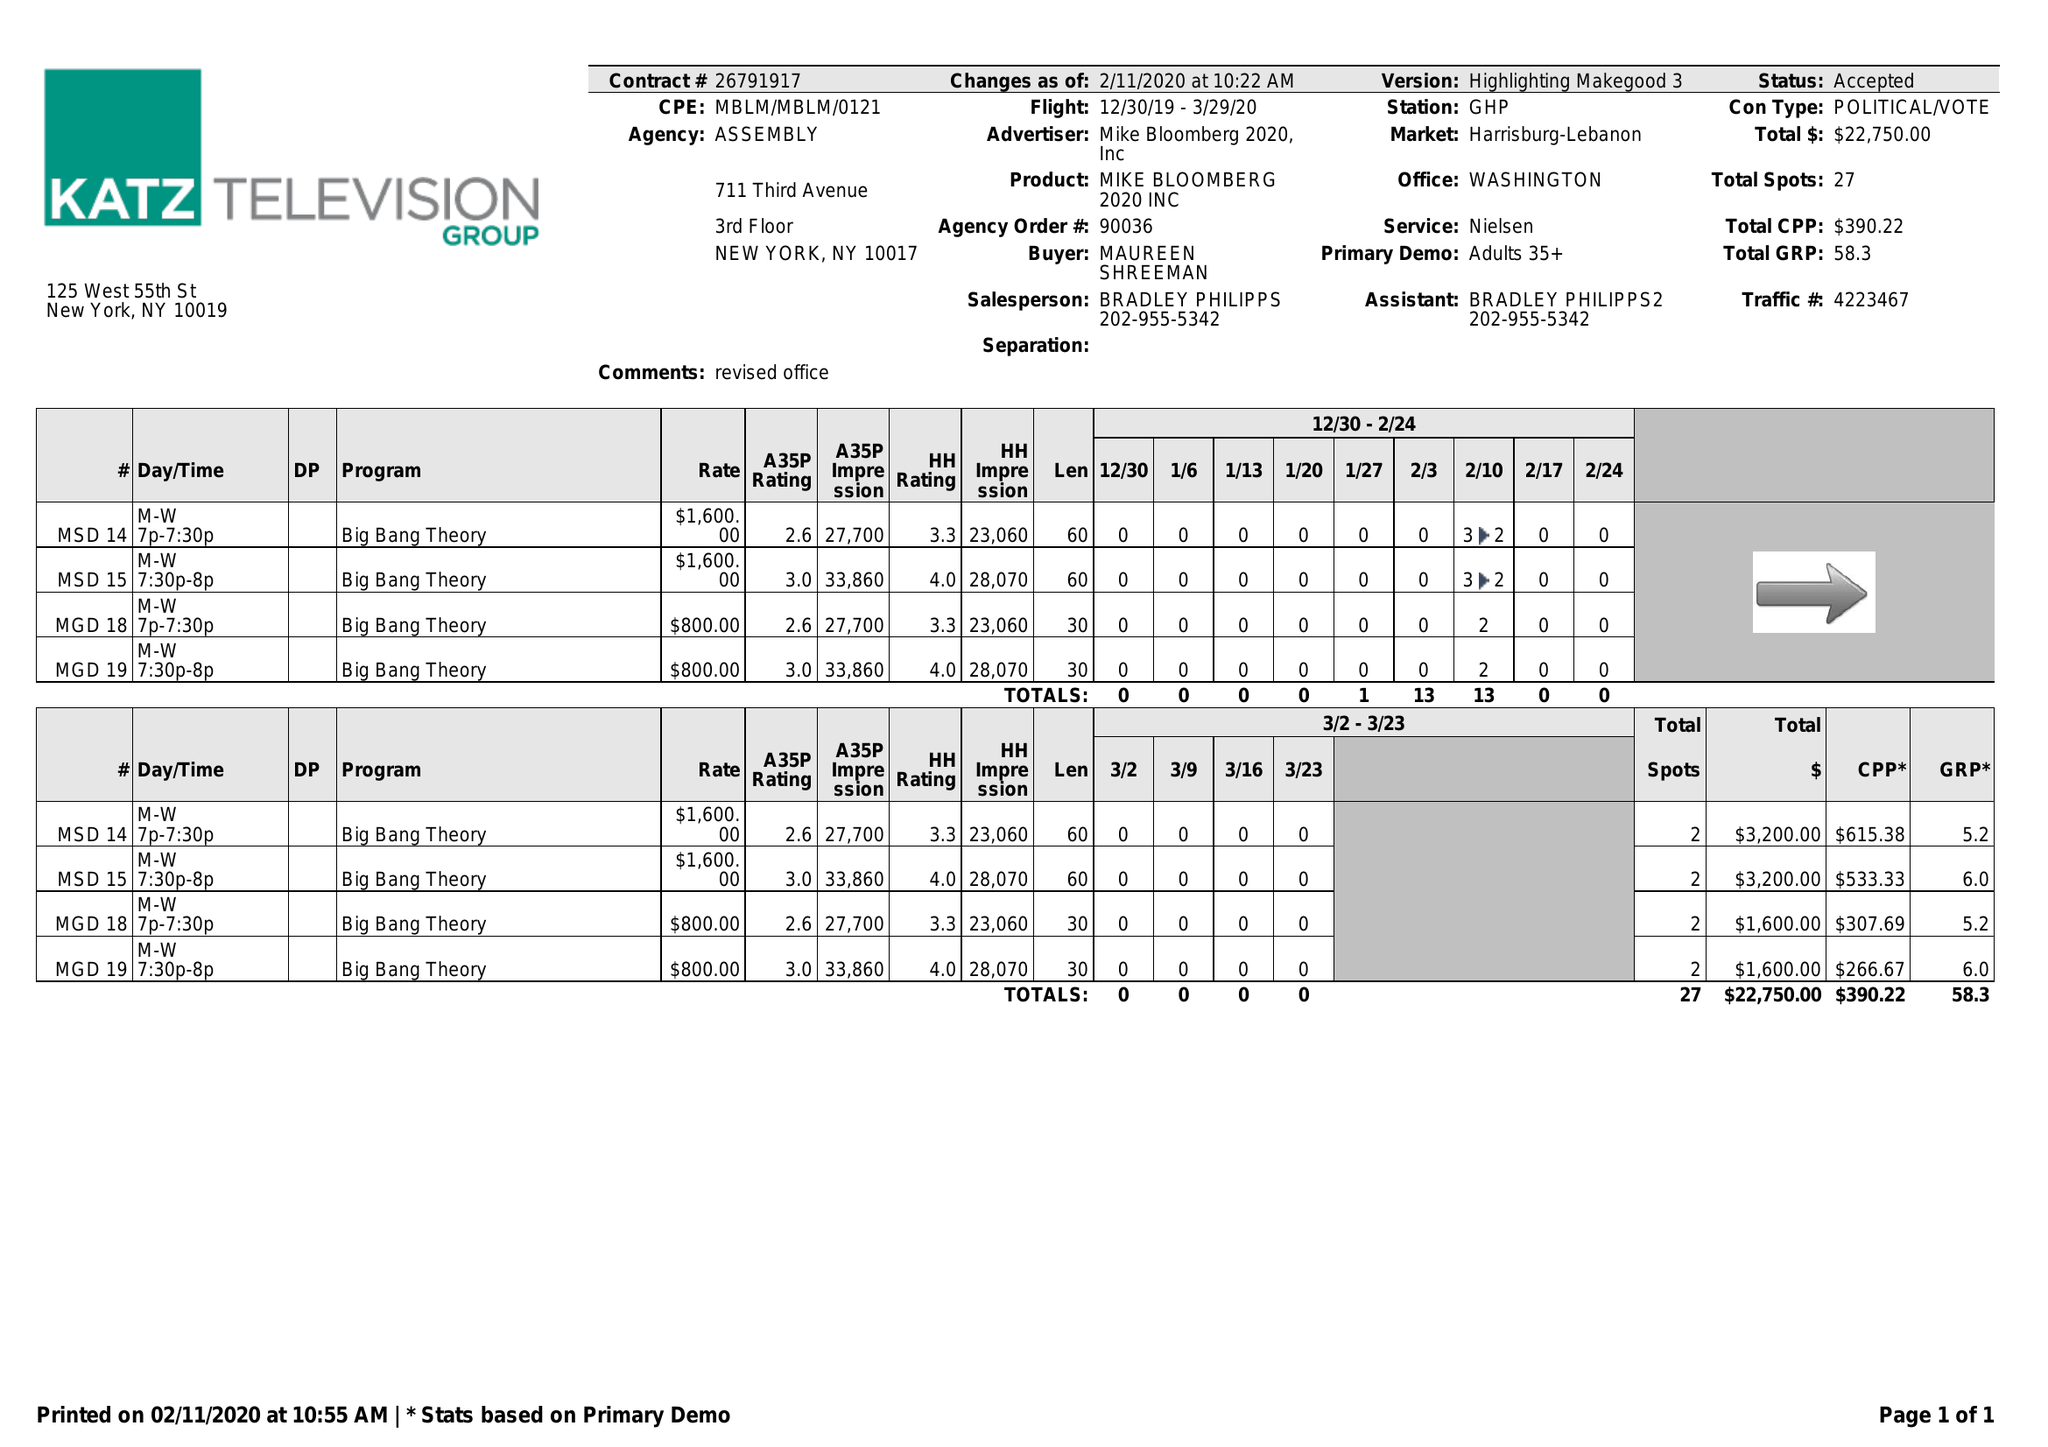What is the value for the flight_from?
Answer the question using a single word or phrase. 12/30/19 